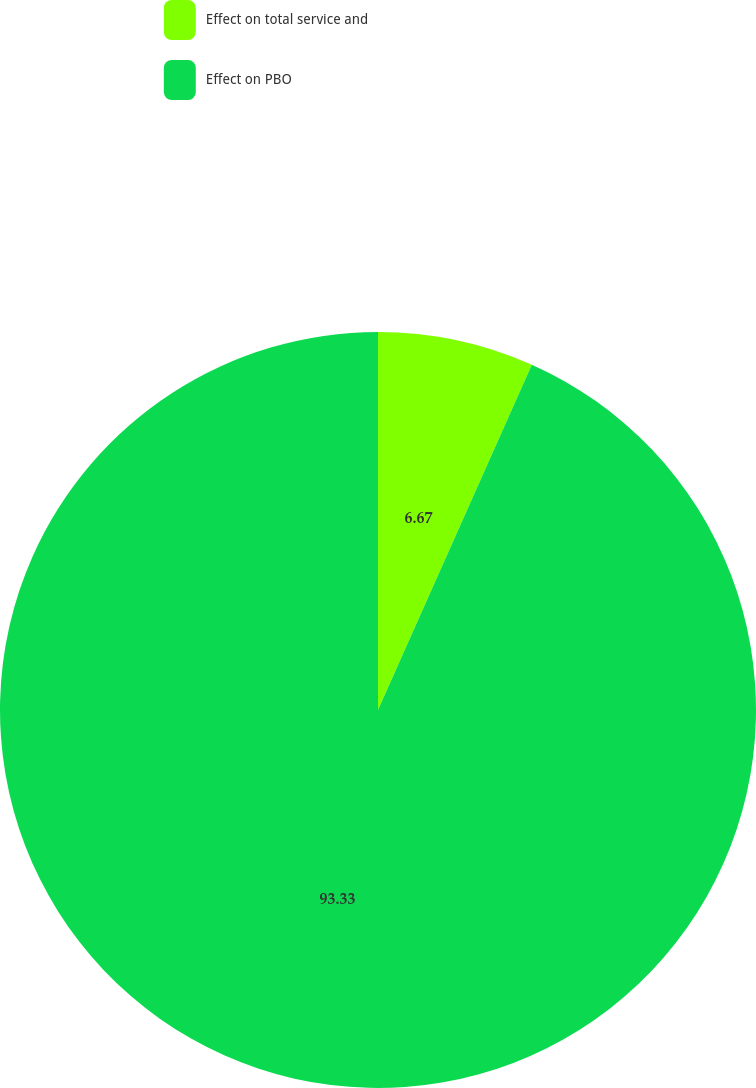Convert chart to OTSL. <chart><loc_0><loc_0><loc_500><loc_500><pie_chart><fcel>Effect on total service and<fcel>Effect on PBO<nl><fcel>6.67%<fcel>93.33%<nl></chart> 